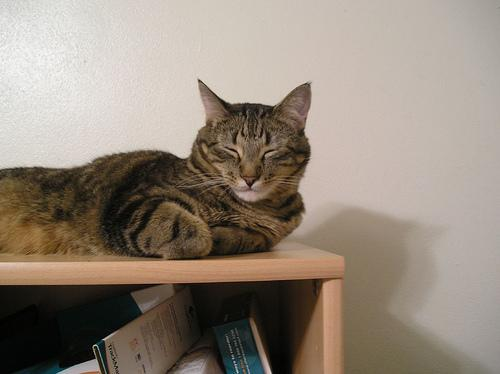What is the cat on top of? Please explain your reasoning. book shelf. A cat is laying in a shelving unit with books on the shelf below. 